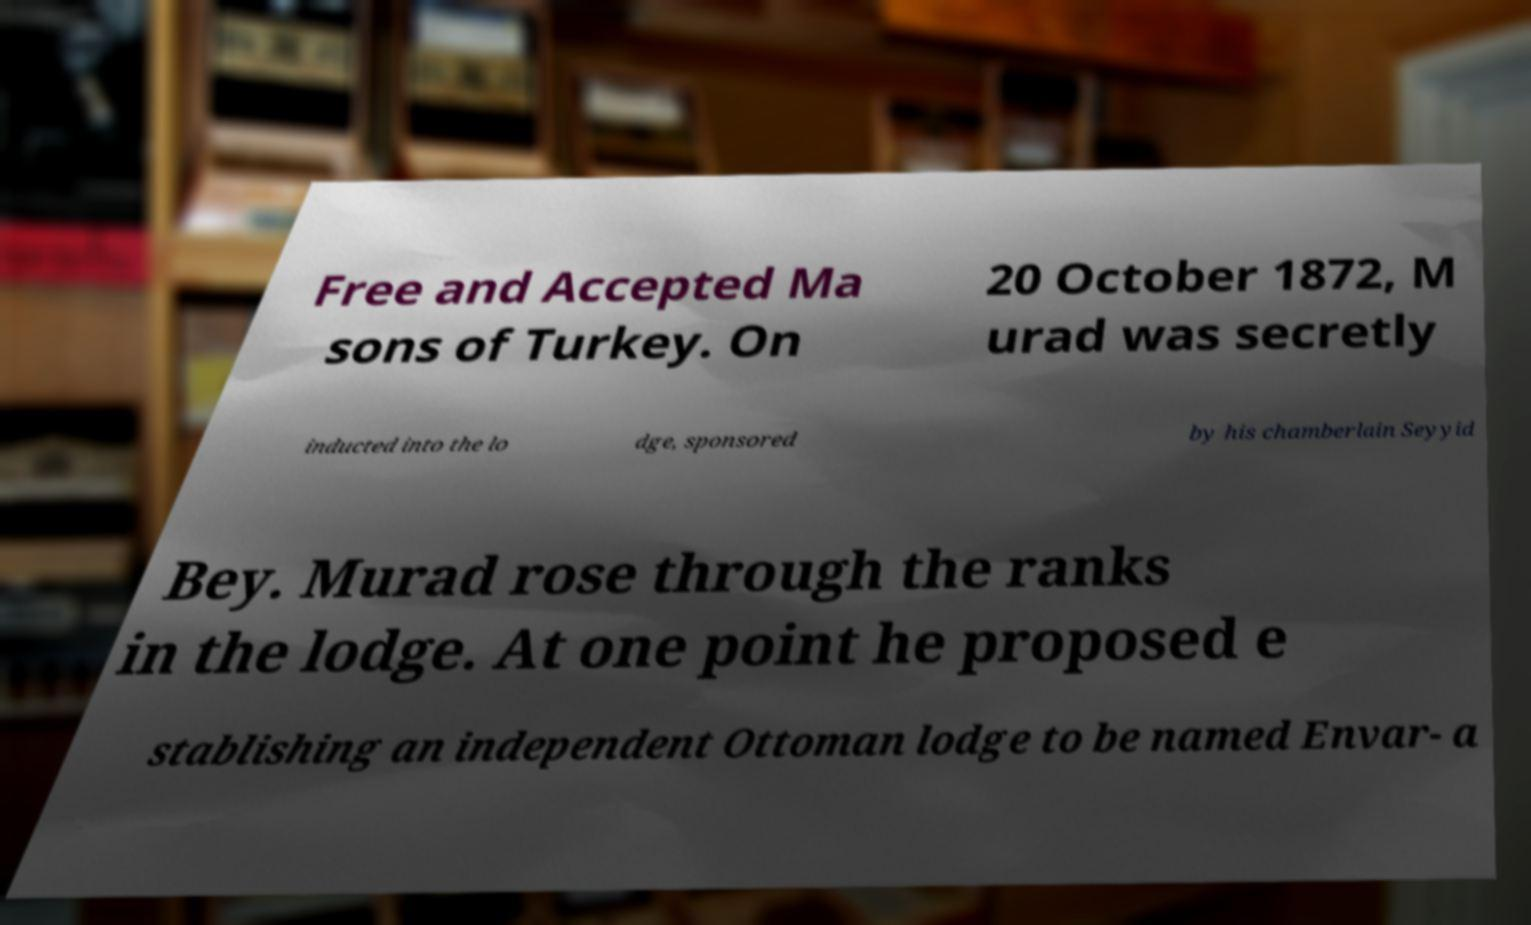Can you read and provide the text displayed in the image?This photo seems to have some interesting text. Can you extract and type it out for me? Free and Accepted Ma sons of Turkey. On 20 October 1872, M urad was secretly inducted into the lo dge, sponsored by his chamberlain Seyyid Bey. Murad rose through the ranks in the lodge. At one point he proposed e stablishing an independent Ottoman lodge to be named Envar- a 